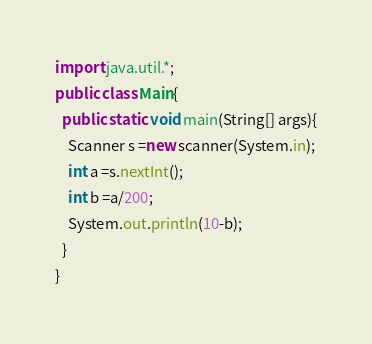Convert code to text. <code><loc_0><loc_0><loc_500><loc_500><_Java_>import java.util.*;
public class Main{
  public static void main(String[] args){
    Scanner s =new scanner(System.in);
    int a =s.nextInt();
    int b =a/200;
    System.out.println(10-b);
  }
}</code> 